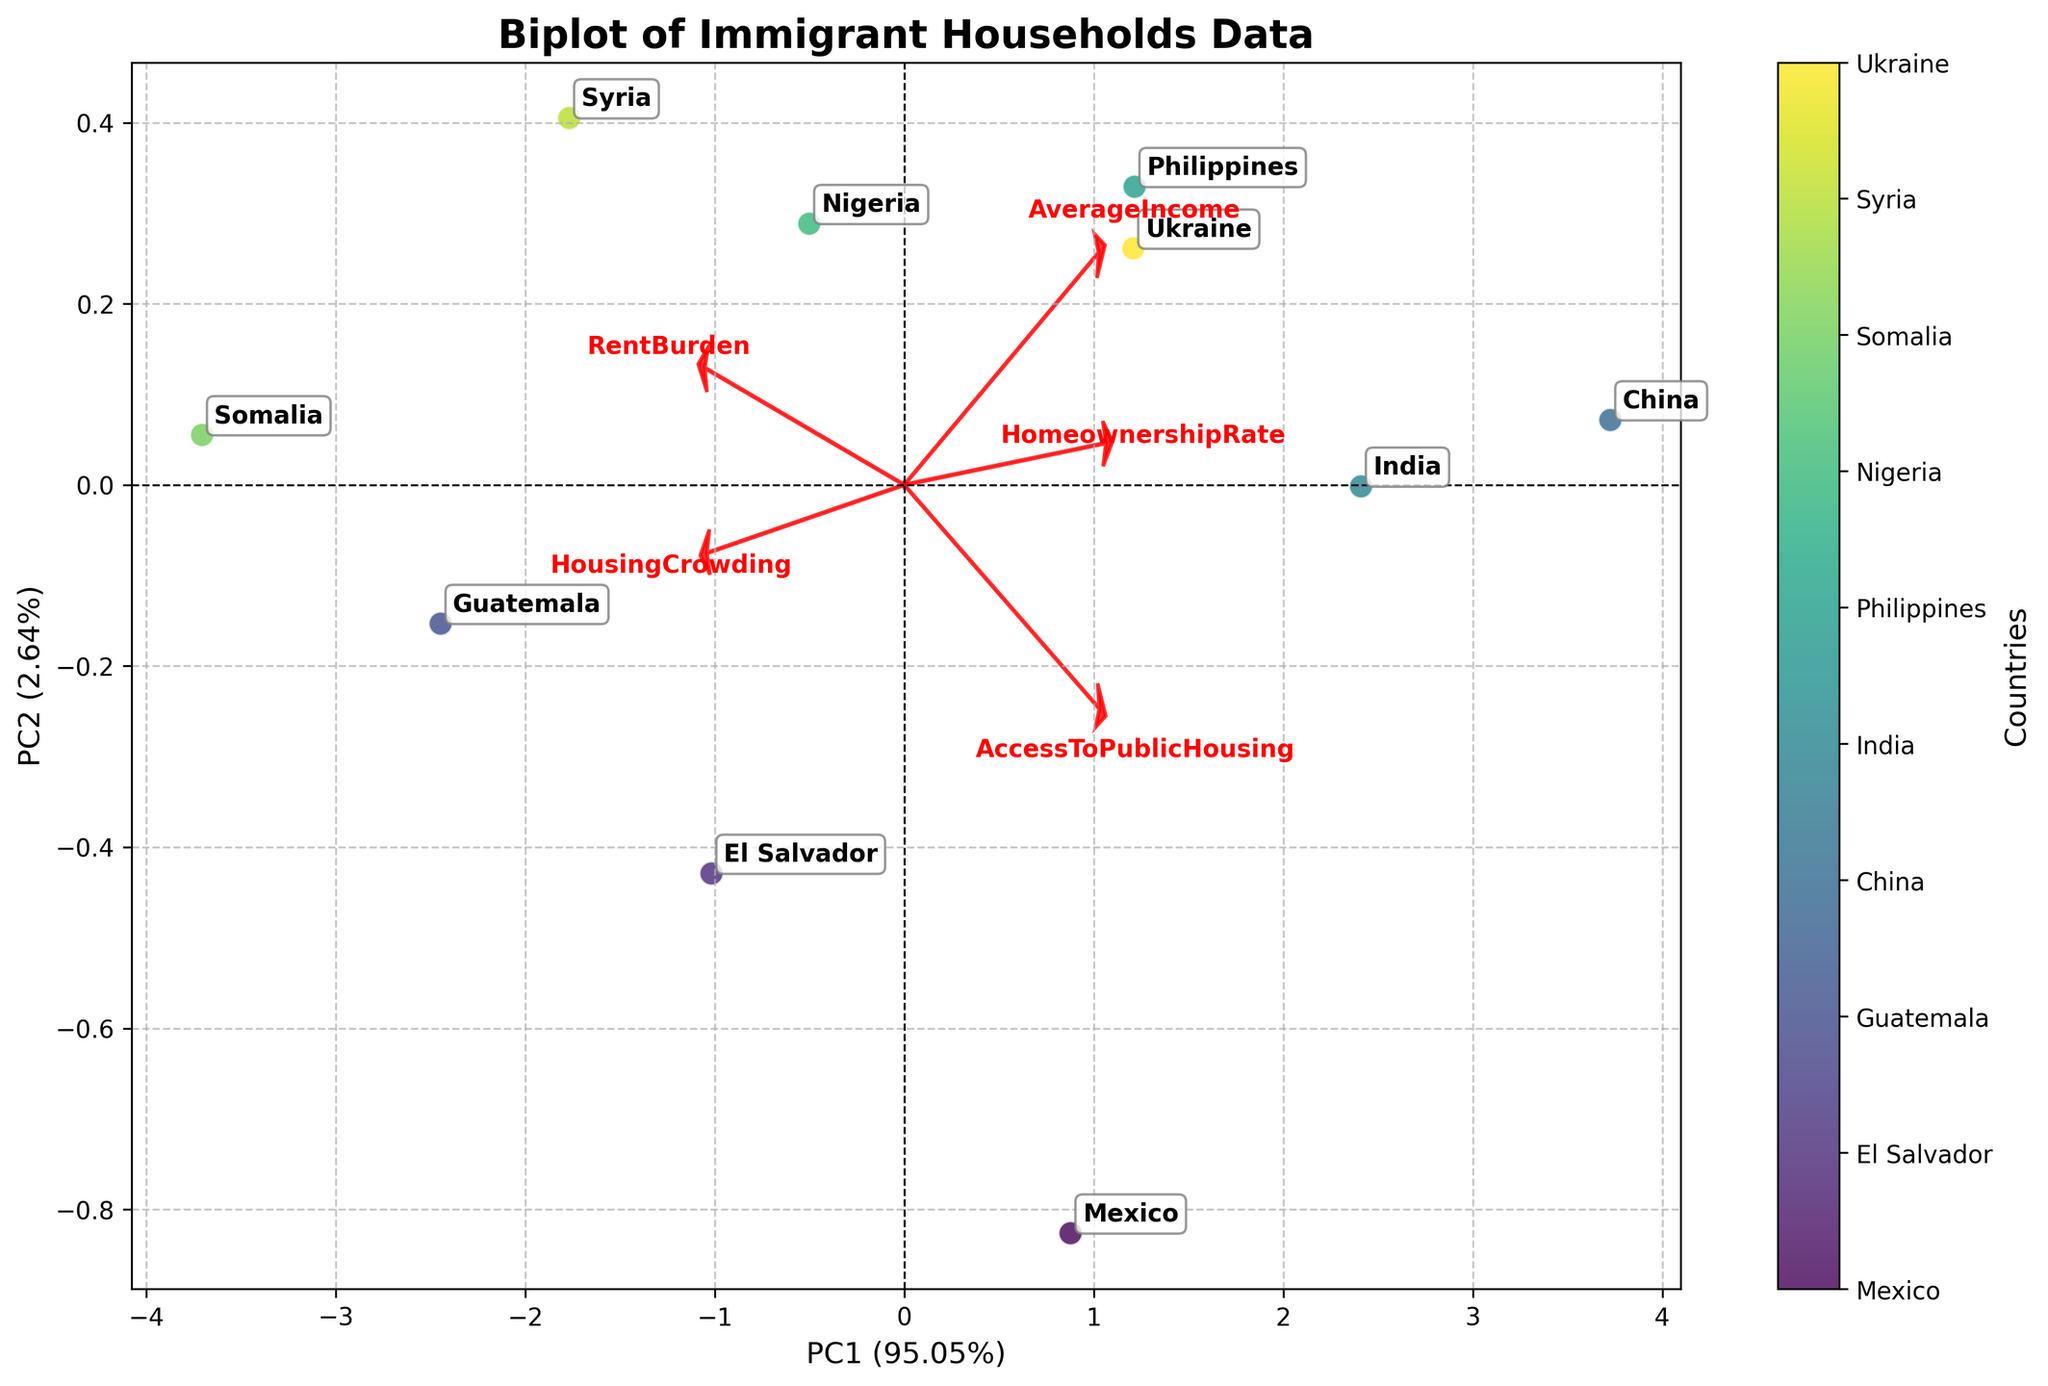What is the title of the figure? The title is a descriptive text at the top of the figure providing the general information about what's being presented. Here, the title is "Biplot of Immigrant Households Data"
Answer: Biplot of Immigrant Households Data How many countries are represented in the biplot? Each country is annotated with its name, and there are distinct points scattered across the plot. Counting these annotations will give the total number of countries.
Answer: 10 Which country has the highest average income? Average income is a variable represented in the dataset. By looking at the annotated countries and their respective positions related to the loadings vector of "AverageIncome," we can identify the highest one. China has the highest average income since its position aligns closest to the loading vector pointing towards higher income.
Answer: China How does the homeownership rate vary with average income? Homeownership rate increases as the average income increases. This relationship can be observed by looking at the positions of the vectors for "AverageIncome" and "HomeownershipRate," which point in roughly the same direction.
Answer: Increases Which country exhibits the lowest rent burden? Locate the annotated country points. Ukraine is positioned closest to the low values on the "RentBurden" loading vector, indicating it has the lowest rent burden.
Answer: Ukraine Is there a visible correlation between housing crowding and rent burden? To find the relationship between these two variables, examine the vectors of "HousingCrowding" and "RentBurden." The vectors are nearly pointing in the same direction, suggesting a positive correlation.
Answer: Yes, there is a positive correlation Between India and Nigeria, which country shows a higher level of housing crowding? Compare the positions of India and Nigeria relative to the "HousingCrowding" vector. Nigeria is positioned further along this vector compared to India.
Answer: Nigeria Which data point is closest to the origin, and what does it imply? The point closest to the origin has the least deviation from the mean for all the variables represented in the biplot. Ukraine appears closest to the origin, implying its values are average for the data set.
Answer: Ukraine What does the arrow direction of 'AccessToPublicHousing' indicate compared to 'HomeownershipRate'? The direction of 'AccessToPublicHousing' is nearly opposite to 'HomeownershipRate,' indicating that higher access to public housing correlates with lower homeownership rates
Answer: Opposite correlation 